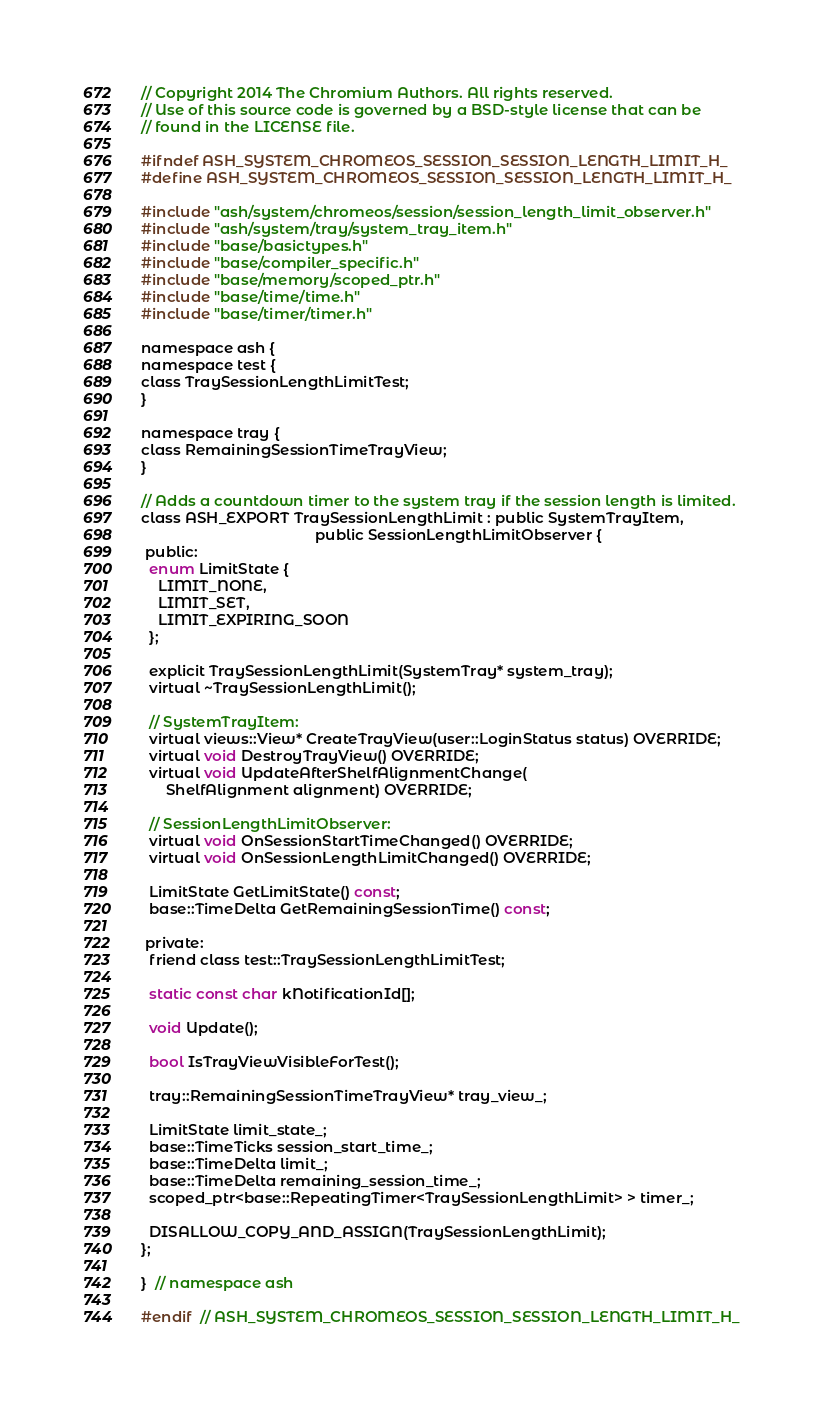Convert code to text. <code><loc_0><loc_0><loc_500><loc_500><_C_>// Copyright 2014 The Chromium Authors. All rights reserved.
// Use of this source code is governed by a BSD-style license that can be
// found in the LICENSE file.

#ifndef ASH_SYSTEM_CHROMEOS_SESSION_SESSION_LENGTH_LIMIT_H_
#define ASH_SYSTEM_CHROMEOS_SESSION_SESSION_LENGTH_LIMIT_H_

#include "ash/system/chromeos/session/session_length_limit_observer.h"
#include "ash/system/tray/system_tray_item.h"
#include "base/basictypes.h"
#include "base/compiler_specific.h"
#include "base/memory/scoped_ptr.h"
#include "base/time/time.h"
#include "base/timer/timer.h"

namespace ash {
namespace test {
class TraySessionLengthLimitTest;
}

namespace tray {
class RemainingSessionTimeTrayView;
}

// Adds a countdown timer to the system tray if the session length is limited.
class ASH_EXPORT TraySessionLengthLimit : public SystemTrayItem,
                                          public SessionLengthLimitObserver {
 public:
  enum LimitState {
    LIMIT_NONE,
    LIMIT_SET,
    LIMIT_EXPIRING_SOON
  };

  explicit TraySessionLengthLimit(SystemTray* system_tray);
  virtual ~TraySessionLengthLimit();

  // SystemTrayItem:
  virtual views::View* CreateTrayView(user::LoginStatus status) OVERRIDE;
  virtual void DestroyTrayView() OVERRIDE;
  virtual void UpdateAfterShelfAlignmentChange(
      ShelfAlignment alignment) OVERRIDE;

  // SessionLengthLimitObserver:
  virtual void OnSessionStartTimeChanged() OVERRIDE;
  virtual void OnSessionLengthLimitChanged() OVERRIDE;

  LimitState GetLimitState() const;
  base::TimeDelta GetRemainingSessionTime() const;

 private:
  friend class test::TraySessionLengthLimitTest;

  static const char kNotificationId[];

  void Update();

  bool IsTrayViewVisibleForTest();

  tray::RemainingSessionTimeTrayView* tray_view_;

  LimitState limit_state_;
  base::TimeTicks session_start_time_;
  base::TimeDelta limit_;
  base::TimeDelta remaining_session_time_;
  scoped_ptr<base::RepeatingTimer<TraySessionLengthLimit> > timer_;

  DISALLOW_COPY_AND_ASSIGN(TraySessionLengthLimit);
};

}  // namespace ash

#endif  // ASH_SYSTEM_CHROMEOS_SESSION_SESSION_LENGTH_LIMIT_H_
</code> 